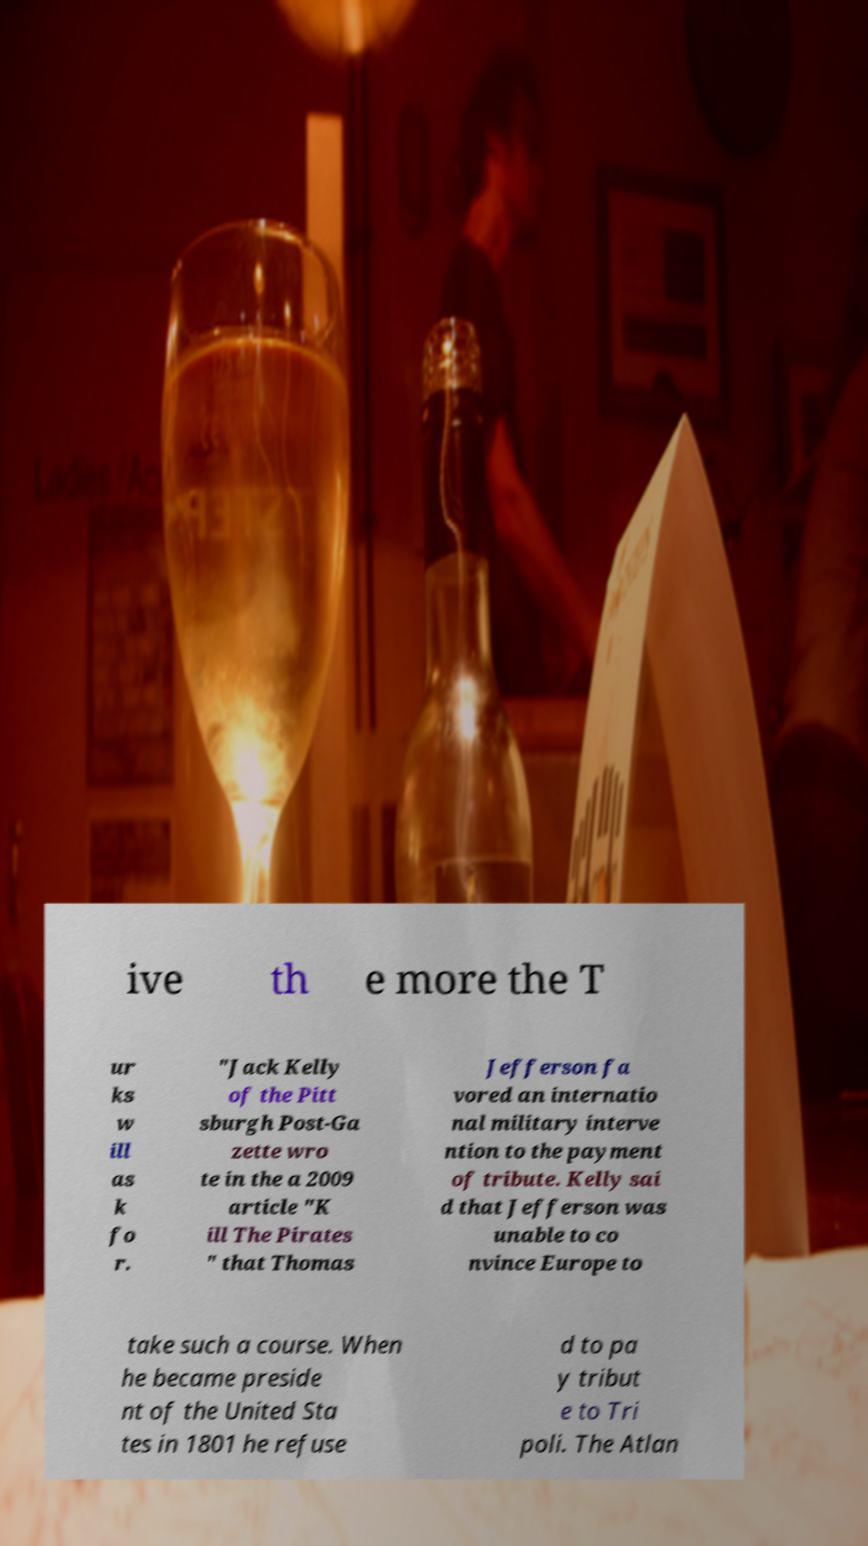Can you read and provide the text displayed in the image?This photo seems to have some interesting text. Can you extract and type it out for me? ive th e more the T ur ks w ill as k fo r. "Jack Kelly of the Pitt sburgh Post-Ga zette wro te in the a 2009 article "K ill The Pirates " that Thomas Jefferson fa vored an internatio nal military interve ntion to the payment of tribute. Kelly sai d that Jefferson was unable to co nvince Europe to take such a course. When he became preside nt of the United Sta tes in 1801 he refuse d to pa y tribut e to Tri poli. The Atlan 